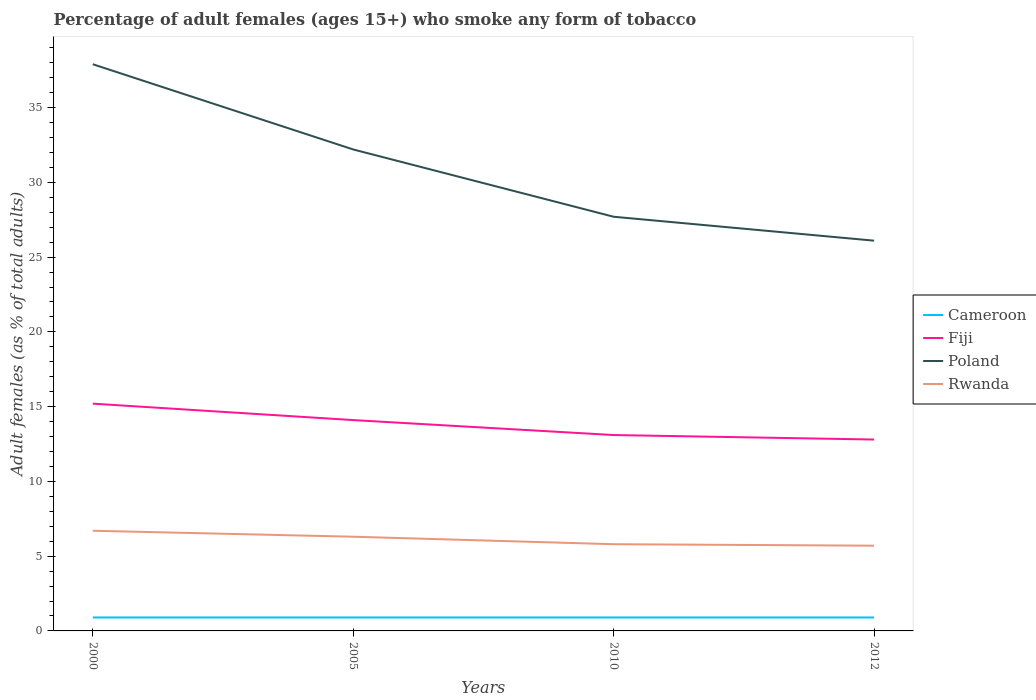How many different coloured lines are there?
Provide a short and direct response. 4. Does the line corresponding to Rwanda intersect with the line corresponding to Poland?
Your response must be concise. No. Across all years, what is the maximum percentage of adult females who smoke in Poland?
Your answer should be very brief. 26.1. What is the total percentage of adult females who smoke in Poland in the graph?
Your answer should be very brief. 11.8. What is the difference between the highest and the second highest percentage of adult females who smoke in Rwanda?
Provide a succinct answer. 1. What is the difference between the highest and the lowest percentage of adult females who smoke in Rwanda?
Keep it short and to the point. 2. Are the values on the major ticks of Y-axis written in scientific E-notation?
Offer a very short reply. No. Does the graph contain grids?
Provide a succinct answer. No. What is the title of the graph?
Your answer should be very brief. Percentage of adult females (ages 15+) who smoke any form of tobacco. What is the label or title of the X-axis?
Your response must be concise. Years. What is the label or title of the Y-axis?
Ensure brevity in your answer.  Adult females (as % of total adults). What is the Adult females (as % of total adults) of Cameroon in 2000?
Your answer should be very brief. 0.9. What is the Adult females (as % of total adults) in Fiji in 2000?
Your answer should be very brief. 15.2. What is the Adult females (as % of total adults) in Poland in 2000?
Provide a succinct answer. 37.9. What is the Adult females (as % of total adults) of Rwanda in 2000?
Provide a succinct answer. 6.7. What is the Adult females (as % of total adults) of Poland in 2005?
Provide a short and direct response. 32.2. What is the Adult females (as % of total adults) in Cameroon in 2010?
Your answer should be very brief. 0.9. What is the Adult females (as % of total adults) of Fiji in 2010?
Offer a terse response. 13.1. What is the Adult females (as % of total adults) in Poland in 2010?
Ensure brevity in your answer.  27.7. What is the Adult females (as % of total adults) of Poland in 2012?
Give a very brief answer. 26.1. Across all years, what is the maximum Adult females (as % of total adults) in Cameroon?
Offer a terse response. 0.9. Across all years, what is the maximum Adult females (as % of total adults) in Fiji?
Your answer should be compact. 15.2. Across all years, what is the maximum Adult females (as % of total adults) of Poland?
Your answer should be very brief. 37.9. Across all years, what is the maximum Adult females (as % of total adults) in Rwanda?
Your answer should be very brief. 6.7. Across all years, what is the minimum Adult females (as % of total adults) in Cameroon?
Give a very brief answer. 0.9. Across all years, what is the minimum Adult females (as % of total adults) of Fiji?
Your answer should be very brief. 12.8. Across all years, what is the minimum Adult females (as % of total adults) in Poland?
Offer a very short reply. 26.1. Across all years, what is the minimum Adult females (as % of total adults) in Rwanda?
Keep it short and to the point. 5.7. What is the total Adult females (as % of total adults) in Cameroon in the graph?
Provide a succinct answer. 3.6. What is the total Adult females (as % of total adults) in Fiji in the graph?
Your answer should be very brief. 55.2. What is the total Adult females (as % of total adults) in Poland in the graph?
Your response must be concise. 123.9. What is the total Adult females (as % of total adults) of Rwanda in the graph?
Ensure brevity in your answer.  24.5. What is the difference between the Adult females (as % of total adults) in Cameroon in 2000 and that in 2005?
Provide a succinct answer. 0. What is the difference between the Adult females (as % of total adults) of Cameroon in 2000 and that in 2010?
Your answer should be compact. 0. What is the difference between the Adult females (as % of total adults) in Fiji in 2000 and that in 2010?
Provide a short and direct response. 2.1. What is the difference between the Adult females (as % of total adults) of Poland in 2000 and that in 2010?
Your response must be concise. 10.2. What is the difference between the Adult females (as % of total adults) in Cameroon in 2000 and that in 2012?
Provide a short and direct response. 0. What is the difference between the Adult females (as % of total adults) in Fiji in 2000 and that in 2012?
Make the answer very short. 2.4. What is the difference between the Adult females (as % of total adults) of Rwanda in 2000 and that in 2012?
Offer a terse response. 1. What is the difference between the Adult females (as % of total adults) of Cameroon in 2005 and that in 2010?
Provide a short and direct response. 0. What is the difference between the Adult females (as % of total adults) of Fiji in 2005 and that in 2012?
Give a very brief answer. 1.3. What is the difference between the Adult females (as % of total adults) in Poland in 2005 and that in 2012?
Your answer should be very brief. 6.1. What is the difference between the Adult females (as % of total adults) in Rwanda in 2005 and that in 2012?
Your response must be concise. 0.6. What is the difference between the Adult females (as % of total adults) of Poland in 2010 and that in 2012?
Provide a short and direct response. 1.6. What is the difference between the Adult females (as % of total adults) in Cameroon in 2000 and the Adult females (as % of total adults) in Fiji in 2005?
Give a very brief answer. -13.2. What is the difference between the Adult females (as % of total adults) of Cameroon in 2000 and the Adult females (as % of total adults) of Poland in 2005?
Ensure brevity in your answer.  -31.3. What is the difference between the Adult females (as % of total adults) in Cameroon in 2000 and the Adult females (as % of total adults) in Rwanda in 2005?
Keep it short and to the point. -5.4. What is the difference between the Adult females (as % of total adults) in Fiji in 2000 and the Adult females (as % of total adults) in Poland in 2005?
Offer a very short reply. -17. What is the difference between the Adult females (as % of total adults) in Poland in 2000 and the Adult females (as % of total adults) in Rwanda in 2005?
Provide a short and direct response. 31.6. What is the difference between the Adult females (as % of total adults) of Cameroon in 2000 and the Adult females (as % of total adults) of Poland in 2010?
Provide a short and direct response. -26.8. What is the difference between the Adult females (as % of total adults) in Poland in 2000 and the Adult females (as % of total adults) in Rwanda in 2010?
Make the answer very short. 32.1. What is the difference between the Adult females (as % of total adults) in Cameroon in 2000 and the Adult females (as % of total adults) in Fiji in 2012?
Ensure brevity in your answer.  -11.9. What is the difference between the Adult females (as % of total adults) in Cameroon in 2000 and the Adult females (as % of total adults) in Poland in 2012?
Offer a very short reply. -25.2. What is the difference between the Adult females (as % of total adults) in Fiji in 2000 and the Adult females (as % of total adults) in Rwanda in 2012?
Your response must be concise. 9.5. What is the difference between the Adult females (as % of total adults) of Poland in 2000 and the Adult females (as % of total adults) of Rwanda in 2012?
Make the answer very short. 32.2. What is the difference between the Adult females (as % of total adults) in Cameroon in 2005 and the Adult females (as % of total adults) in Fiji in 2010?
Your answer should be very brief. -12.2. What is the difference between the Adult females (as % of total adults) of Cameroon in 2005 and the Adult females (as % of total adults) of Poland in 2010?
Your answer should be very brief. -26.8. What is the difference between the Adult females (as % of total adults) in Fiji in 2005 and the Adult females (as % of total adults) in Poland in 2010?
Your answer should be compact. -13.6. What is the difference between the Adult females (as % of total adults) in Poland in 2005 and the Adult females (as % of total adults) in Rwanda in 2010?
Provide a short and direct response. 26.4. What is the difference between the Adult females (as % of total adults) of Cameroon in 2005 and the Adult females (as % of total adults) of Poland in 2012?
Your answer should be compact. -25.2. What is the difference between the Adult females (as % of total adults) of Fiji in 2005 and the Adult females (as % of total adults) of Rwanda in 2012?
Your answer should be compact. 8.4. What is the difference between the Adult females (as % of total adults) of Cameroon in 2010 and the Adult females (as % of total adults) of Fiji in 2012?
Provide a succinct answer. -11.9. What is the difference between the Adult females (as % of total adults) in Cameroon in 2010 and the Adult females (as % of total adults) in Poland in 2012?
Give a very brief answer. -25.2. What is the difference between the Adult females (as % of total adults) in Cameroon in 2010 and the Adult females (as % of total adults) in Rwanda in 2012?
Your response must be concise. -4.8. What is the difference between the Adult females (as % of total adults) of Fiji in 2010 and the Adult females (as % of total adults) of Poland in 2012?
Ensure brevity in your answer.  -13. What is the difference between the Adult females (as % of total adults) of Fiji in 2010 and the Adult females (as % of total adults) of Rwanda in 2012?
Make the answer very short. 7.4. What is the average Adult females (as % of total adults) in Poland per year?
Keep it short and to the point. 30.98. What is the average Adult females (as % of total adults) in Rwanda per year?
Offer a terse response. 6.12. In the year 2000, what is the difference between the Adult females (as % of total adults) of Cameroon and Adult females (as % of total adults) of Fiji?
Give a very brief answer. -14.3. In the year 2000, what is the difference between the Adult females (as % of total adults) of Cameroon and Adult females (as % of total adults) of Poland?
Ensure brevity in your answer.  -37. In the year 2000, what is the difference between the Adult females (as % of total adults) of Cameroon and Adult females (as % of total adults) of Rwanda?
Offer a very short reply. -5.8. In the year 2000, what is the difference between the Adult females (as % of total adults) in Fiji and Adult females (as % of total adults) in Poland?
Your answer should be very brief. -22.7. In the year 2000, what is the difference between the Adult females (as % of total adults) of Poland and Adult females (as % of total adults) of Rwanda?
Your response must be concise. 31.2. In the year 2005, what is the difference between the Adult females (as % of total adults) of Cameroon and Adult females (as % of total adults) of Fiji?
Your answer should be compact. -13.2. In the year 2005, what is the difference between the Adult females (as % of total adults) in Cameroon and Adult females (as % of total adults) in Poland?
Ensure brevity in your answer.  -31.3. In the year 2005, what is the difference between the Adult females (as % of total adults) in Fiji and Adult females (as % of total adults) in Poland?
Offer a very short reply. -18.1. In the year 2005, what is the difference between the Adult females (as % of total adults) of Poland and Adult females (as % of total adults) of Rwanda?
Offer a terse response. 25.9. In the year 2010, what is the difference between the Adult females (as % of total adults) of Cameroon and Adult females (as % of total adults) of Fiji?
Ensure brevity in your answer.  -12.2. In the year 2010, what is the difference between the Adult females (as % of total adults) in Cameroon and Adult females (as % of total adults) in Poland?
Provide a short and direct response. -26.8. In the year 2010, what is the difference between the Adult females (as % of total adults) in Cameroon and Adult females (as % of total adults) in Rwanda?
Offer a very short reply. -4.9. In the year 2010, what is the difference between the Adult females (as % of total adults) of Fiji and Adult females (as % of total adults) of Poland?
Give a very brief answer. -14.6. In the year 2010, what is the difference between the Adult females (as % of total adults) of Fiji and Adult females (as % of total adults) of Rwanda?
Offer a very short reply. 7.3. In the year 2010, what is the difference between the Adult females (as % of total adults) in Poland and Adult females (as % of total adults) in Rwanda?
Your response must be concise. 21.9. In the year 2012, what is the difference between the Adult females (as % of total adults) in Cameroon and Adult females (as % of total adults) in Poland?
Provide a succinct answer. -25.2. In the year 2012, what is the difference between the Adult females (as % of total adults) of Cameroon and Adult females (as % of total adults) of Rwanda?
Provide a succinct answer. -4.8. In the year 2012, what is the difference between the Adult females (as % of total adults) of Fiji and Adult females (as % of total adults) of Poland?
Make the answer very short. -13.3. In the year 2012, what is the difference between the Adult females (as % of total adults) in Poland and Adult females (as % of total adults) in Rwanda?
Your answer should be very brief. 20.4. What is the ratio of the Adult females (as % of total adults) of Cameroon in 2000 to that in 2005?
Provide a short and direct response. 1. What is the ratio of the Adult females (as % of total adults) of Fiji in 2000 to that in 2005?
Your answer should be compact. 1.08. What is the ratio of the Adult females (as % of total adults) of Poland in 2000 to that in 2005?
Provide a succinct answer. 1.18. What is the ratio of the Adult females (as % of total adults) in Rwanda in 2000 to that in 2005?
Offer a terse response. 1.06. What is the ratio of the Adult females (as % of total adults) of Fiji in 2000 to that in 2010?
Offer a terse response. 1.16. What is the ratio of the Adult females (as % of total adults) of Poland in 2000 to that in 2010?
Keep it short and to the point. 1.37. What is the ratio of the Adult females (as % of total adults) in Rwanda in 2000 to that in 2010?
Provide a succinct answer. 1.16. What is the ratio of the Adult females (as % of total adults) in Fiji in 2000 to that in 2012?
Your answer should be very brief. 1.19. What is the ratio of the Adult females (as % of total adults) in Poland in 2000 to that in 2012?
Ensure brevity in your answer.  1.45. What is the ratio of the Adult females (as % of total adults) of Rwanda in 2000 to that in 2012?
Your response must be concise. 1.18. What is the ratio of the Adult females (as % of total adults) in Cameroon in 2005 to that in 2010?
Keep it short and to the point. 1. What is the ratio of the Adult females (as % of total adults) in Fiji in 2005 to that in 2010?
Ensure brevity in your answer.  1.08. What is the ratio of the Adult females (as % of total adults) in Poland in 2005 to that in 2010?
Provide a short and direct response. 1.16. What is the ratio of the Adult females (as % of total adults) of Rwanda in 2005 to that in 2010?
Your answer should be very brief. 1.09. What is the ratio of the Adult females (as % of total adults) in Fiji in 2005 to that in 2012?
Offer a terse response. 1.1. What is the ratio of the Adult females (as % of total adults) of Poland in 2005 to that in 2012?
Your response must be concise. 1.23. What is the ratio of the Adult females (as % of total adults) in Rwanda in 2005 to that in 2012?
Offer a terse response. 1.11. What is the ratio of the Adult females (as % of total adults) of Cameroon in 2010 to that in 2012?
Your answer should be very brief. 1. What is the ratio of the Adult females (as % of total adults) of Fiji in 2010 to that in 2012?
Your response must be concise. 1.02. What is the ratio of the Adult females (as % of total adults) of Poland in 2010 to that in 2012?
Offer a very short reply. 1.06. What is the ratio of the Adult females (as % of total adults) of Rwanda in 2010 to that in 2012?
Your answer should be very brief. 1.02. What is the difference between the highest and the second highest Adult females (as % of total adults) in Cameroon?
Your answer should be very brief. 0. What is the difference between the highest and the lowest Adult females (as % of total adults) in Poland?
Your answer should be compact. 11.8. 